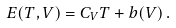Convert formula to latex. <formula><loc_0><loc_0><loc_500><loc_500>E ( T , V ) = C _ { V } T + b ( V ) \, .</formula> 